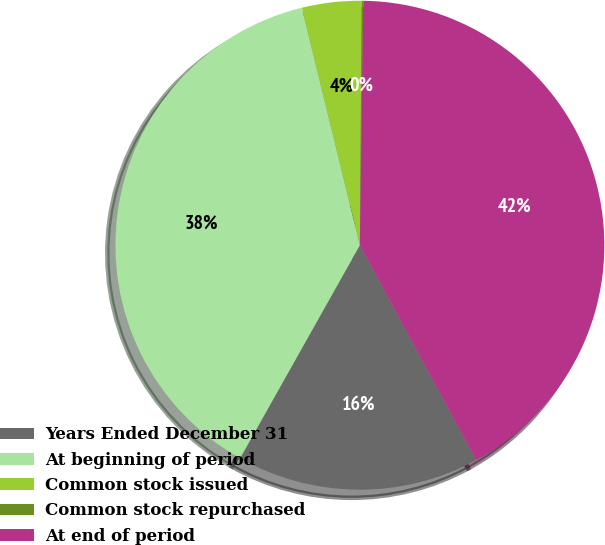Convert chart to OTSL. <chart><loc_0><loc_0><loc_500><loc_500><pie_chart><fcel>Years Ended December 31<fcel>At beginning of period<fcel>Common stock issued<fcel>Common stock repurchased<fcel>At end of period<nl><fcel>16.05%<fcel>38.03%<fcel>3.94%<fcel>0.1%<fcel>41.88%<nl></chart> 